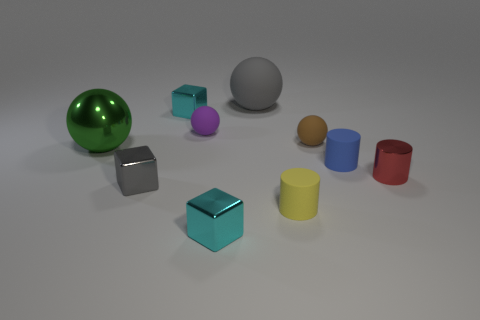How many things are large balls behind the metallic sphere or small metal cylinders?
Provide a succinct answer. 2. What is the size of the thing that is both left of the yellow cylinder and in front of the tiny gray object?
Your response must be concise. Small. There is a block that is the same color as the large rubber ball; what is its size?
Your answer should be very brief. Small. How many other things are the same size as the red metallic cylinder?
Give a very brief answer. 7. What is the color of the big object that is to the right of the small matte thing that is left of the large thing to the right of the gray metallic thing?
Your answer should be very brief. Gray. What shape is the thing that is to the right of the brown matte sphere and left of the red metallic cylinder?
Ensure brevity in your answer.  Cylinder. How many other objects are there of the same shape as the large rubber object?
Give a very brief answer. 3. The gray object behind the small cyan object behind the small cyan cube in front of the green sphere is what shape?
Offer a very short reply. Sphere. How many things are either tiny red metal cylinders or small objects that are to the right of the big gray sphere?
Give a very brief answer. 4. There is a small cyan shiny thing in front of the large green shiny thing; does it have the same shape as the gray object that is in front of the large metallic thing?
Keep it short and to the point. Yes. 